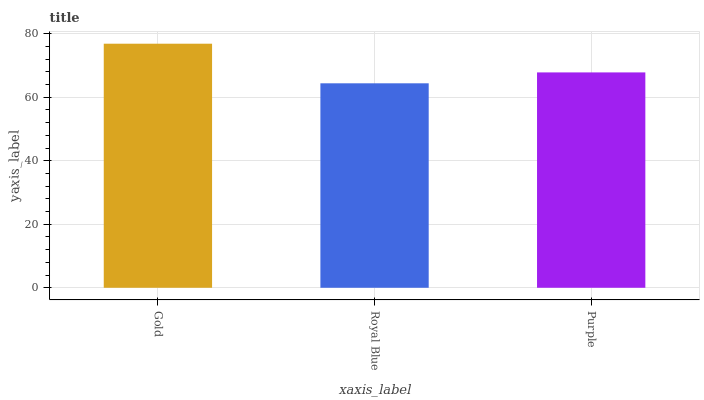Is Purple the minimum?
Answer yes or no. No. Is Purple the maximum?
Answer yes or no. No. Is Purple greater than Royal Blue?
Answer yes or no. Yes. Is Royal Blue less than Purple?
Answer yes or no. Yes. Is Royal Blue greater than Purple?
Answer yes or no. No. Is Purple less than Royal Blue?
Answer yes or no. No. Is Purple the high median?
Answer yes or no. Yes. Is Purple the low median?
Answer yes or no. Yes. Is Gold the high median?
Answer yes or no. No. Is Royal Blue the low median?
Answer yes or no. No. 